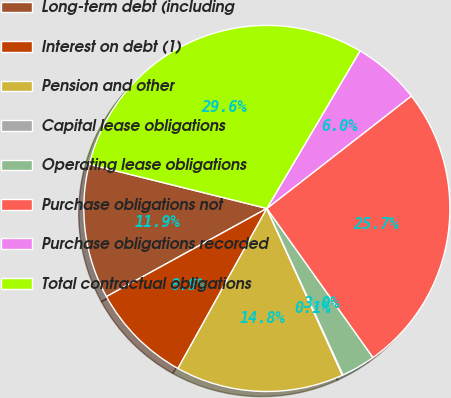<chart> <loc_0><loc_0><loc_500><loc_500><pie_chart><fcel>Long-term debt (including<fcel>Interest on debt (1)<fcel>Pension and other<fcel>Capital lease obligations<fcel>Operating lease obligations<fcel>Purchase obligations not<fcel>Purchase obligations recorded<fcel>Total contractual obligations<nl><fcel>11.88%<fcel>8.93%<fcel>14.84%<fcel>0.06%<fcel>3.02%<fcel>25.68%<fcel>5.97%<fcel>29.62%<nl></chart> 